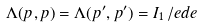Convert formula to latex. <formula><loc_0><loc_0><loc_500><loc_500>\Lambda ( p , p ) = \Lambda ( p ^ { \prime } , p ^ { \prime } ) = I _ { 1 } \, \slash e d { e }</formula> 